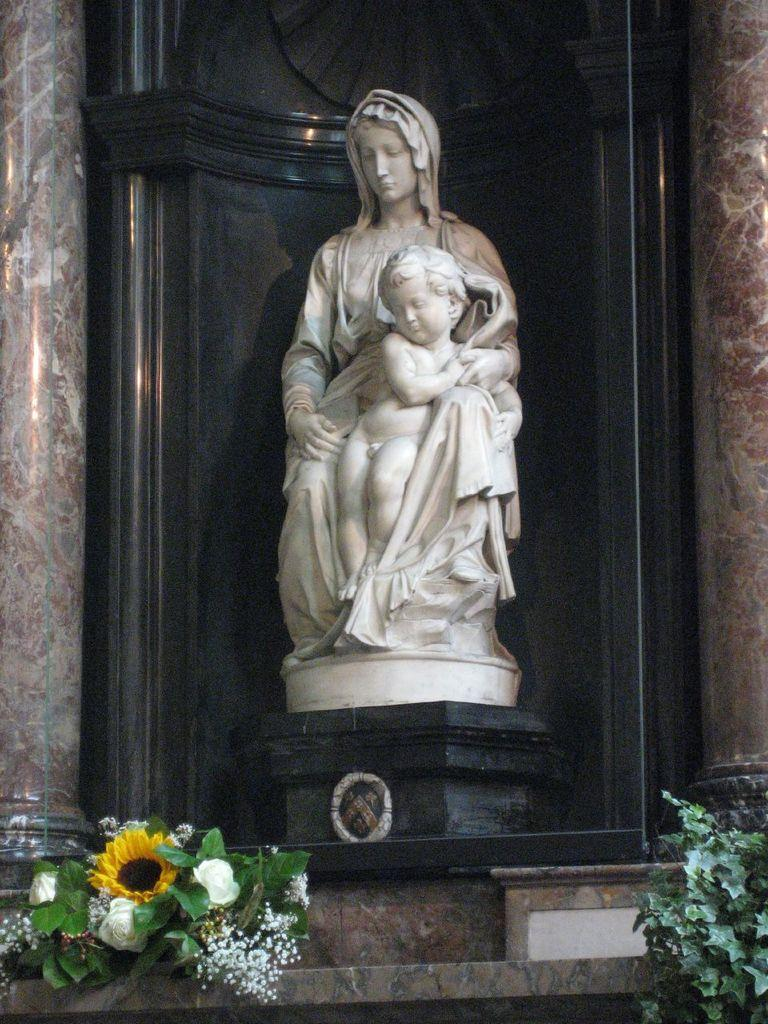What type of plants can be seen in the image? There are flowers and leaves in the image. What is the main structure in the image? There is a statue in the image. What architectural elements are present beside the statue? There are pillars beside the statue in the image. What type of pickle is the judge holding in the image? There is no judge or pickle present in the image. What achievement is the achiever celebrating in the image? There is no achiever or celebration present in the image. 